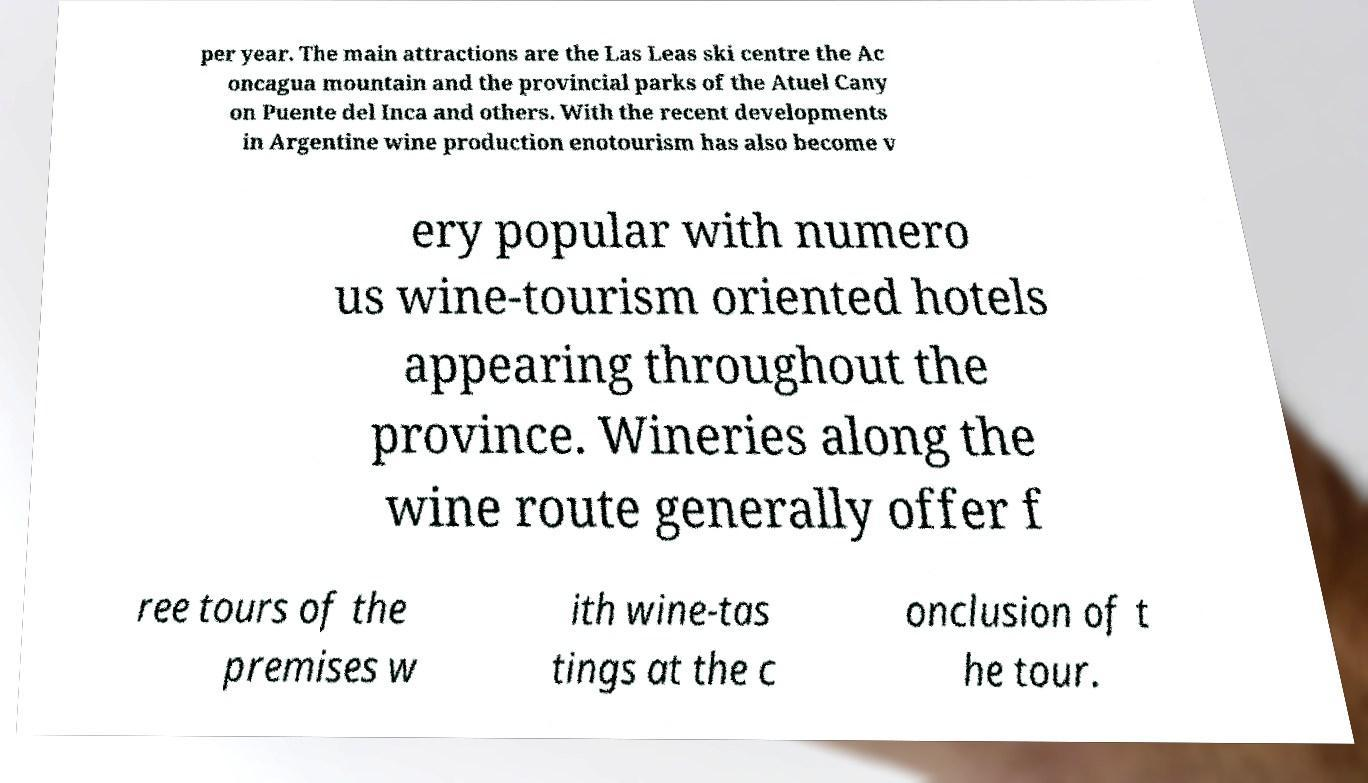Can you read and provide the text displayed in the image?This photo seems to have some interesting text. Can you extract and type it out for me? per year. The main attractions are the Las Leas ski centre the Ac oncagua mountain and the provincial parks of the Atuel Cany on Puente del Inca and others. With the recent developments in Argentine wine production enotourism has also become v ery popular with numero us wine-tourism oriented hotels appearing throughout the province. Wineries along the wine route generally offer f ree tours of the premises w ith wine-tas tings at the c onclusion of t he tour. 